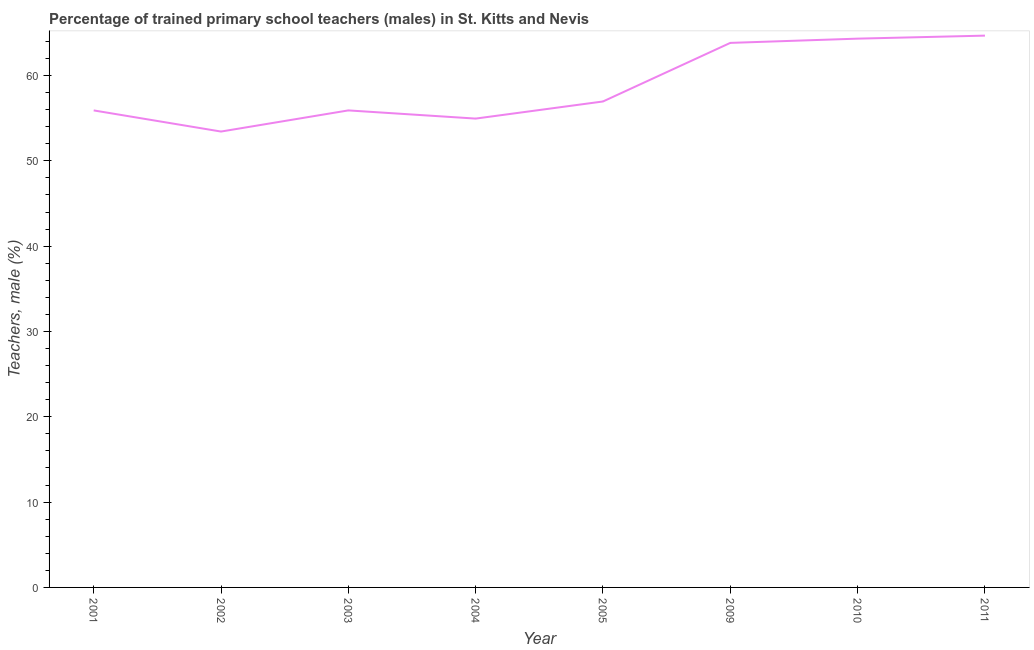What is the percentage of trained male teachers in 2002?
Ensure brevity in your answer.  53.43. Across all years, what is the maximum percentage of trained male teachers?
Ensure brevity in your answer.  64.68. Across all years, what is the minimum percentage of trained male teachers?
Your answer should be compact. 53.43. What is the sum of the percentage of trained male teachers?
Offer a very short reply. 469.99. What is the difference between the percentage of trained male teachers in 2005 and 2011?
Make the answer very short. -7.72. What is the average percentage of trained male teachers per year?
Offer a very short reply. 58.75. What is the median percentage of trained male teachers?
Ensure brevity in your answer.  56.43. In how many years, is the percentage of trained male teachers greater than 36 %?
Your answer should be very brief. 8. Do a majority of the years between 2009 and 2011 (inclusive) have percentage of trained male teachers greater than 46 %?
Your answer should be very brief. Yes. What is the ratio of the percentage of trained male teachers in 2004 to that in 2010?
Provide a succinct answer. 0.85. Is the percentage of trained male teachers in 2003 less than that in 2010?
Make the answer very short. Yes. Is the difference between the percentage of trained male teachers in 2003 and 2004 greater than the difference between any two years?
Provide a short and direct response. No. What is the difference between the highest and the second highest percentage of trained male teachers?
Your answer should be compact. 0.35. Is the sum of the percentage of trained male teachers in 2002 and 2005 greater than the maximum percentage of trained male teachers across all years?
Your answer should be very brief. Yes. What is the difference between the highest and the lowest percentage of trained male teachers?
Offer a very short reply. 11.24. In how many years, is the percentage of trained male teachers greater than the average percentage of trained male teachers taken over all years?
Offer a very short reply. 3. Does the percentage of trained male teachers monotonically increase over the years?
Provide a succinct answer. No. Are the values on the major ticks of Y-axis written in scientific E-notation?
Provide a succinct answer. No. Does the graph contain any zero values?
Ensure brevity in your answer.  No. What is the title of the graph?
Ensure brevity in your answer.  Percentage of trained primary school teachers (males) in St. Kitts and Nevis. What is the label or title of the X-axis?
Ensure brevity in your answer.  Year. What is the label or title of the Y-axis?
Provide a succinct answer. Teachers, male (%). What is the Teachers, male (%) of 2001?
Ensure brevity in your answer.  55.91. What is the Teachers, male (%) of 2002?
Your response must be concise. 53.43. What is the Teachers, male (%) in 2003?
Keep it short and to the point. 55.91. What is the Teachers, male (%) in 2004?
Provide a succinct answer. 54.95. What is the Teachers, male (%) of 2005?
Offer a very short reply. 56.96. What is the Teachers, male (%) of 2009?
Ensure brevity in your answer.  63.82. What is the Teachers, male (%) of 2010?
Your answer should be compact. 64.32. What is the Teachers, male (%) of 2011?
Offer a terse response. 64.68. What is the difference between the Teachers, male (%) in 2001 and 2002?
Offer a very short reply. 2.48. What is the difference between the Teachers, male (%) in 2001 and 2004?
Provide a short and direct response. 0.96. What is the difference between the Teachers, male (%) in 2001 and 2005?
Your answer should be compact. -1.05. What is the difference between the Teachers, male (%) in 2001 and 2009?
Make the answer very short. -7.91. What is the difference between the Teachers, male (%) in 2001 and 2010?
Your answer should be very brief. -8.41. What is the difference between the Teachers, male (%) in 2001 and 2011?
Your answer should be compact. -8.77. What is the difference between the Teachers, male (%) in 2002 and 2003?
Your answer should be compact. -2.48. What is the difference between the Teachers, male (%) in 2002 and 2004?
Offer a very short reply. -1.52. What is the difference between the Teachers, male (%) in 2002 and 2005?
Your answer should be very brief. -3.53. What is the difference between the Teachers, male (%) in 2002 and 2009?
Give a very brief answer. -10.39. What is the difference between the Teachers, male (%) in 2002 and 2010?
Give a very brief answer. -10.89. What is the difference between the Teachers, male (%) in 2002 and 2011?
Provide a short and direct response. -11.24. What is the difference between the Teachers, male (%) in 2003 and 2004?
Provide a short and direct response. 0.96. What is the difference between the Teachers, male (%) in 2003 and 2005?
Your answer should be compact. -1.05. What is the difference between the Teachers, male (%) in 2003 and 2009?
Offer a very short reply. -7.91. What is the difference between the Teachers, male (%) in 2003 and 2010?
Offer a very short reply. -8.41. What is the difference between the Teachers, male (%) in 2003 and 2011?
Offer a very short reply. -8.77. What is the difference between the Teachers, male (%) in 2004 and 2005?
Keep it short and to the point. -2.01. What is the difference between the Teachers, male (%) in 2004 and 2009?
Make the answer very short. -8.87. What is the difference between the Teachers, male (%) in 2004 and 2010?
Your response must be concise. -9.37. What is the difference between the Teachers, male (%) in 2004 and 2011?
Your answer should be compact. -9.72. What is the difference between the Teachers, male (%) in 2005 and 2009?
Your response must be concise. -6.87. What is the difference between the Teachers, male (%) in 2005 and 2010?
Provide a short and direct response. -7.36. What is the difference between the Teachers, male (%) in 2005 and 2011?
Offer a very short reply. -7.72. What is the difference between the Teachers, male (%) in 2009 and 2010?
Offer a terse response. -0.5. What is the difference between the Teachers, male (%) in 2009 and 2011?
Provide a short and direct response. -0.85. What is the difference between the Teachers, male (%) in 2010 and 2011?
Offer a terse response. -0.35. What is the ratio of the Teachers, male (%) in 2001 to that in 2002?
Your answer should be compact. 1.05. What is the ratio of the Teachers, male (%) in 2001 to that in 2004?
Your answer should be very brief. 1.02. What is the ratio of the Teachers, male (%) in 2001 to that in 2005?
Your answer should be very brief. 0.98. What is the ratio of the Teachers, male (%) in 2001 to that in 2009?
Your answer should be very brief. 0.88. What is the ratio of the Teachers, male (%) in 2001 to that in 2010?
Make the answer very short. 0.87. What is the ratio of the Teachers, male (%) in 2001 to that in 2011?
Give a very brief answer. 0.86. What is the ratio of the Teachers, male (%) in 2002 to that in 2003?
Your response must be concise. 0.96. What is the ratio of the Teachers, male (%) in 2002 to that in 2005?
Make the answer very short. 0.94. What is the ratio of the Teachers, male (%) in 2002 to that in 2009?
Make the answer very short. 0.84. What is the ratio of the Teachers, male (%) in 2002 to that in 2010?
Your answer should be very brief. 0.83. What is the ratio of the Teachers, male (%) in 2002 to that in 2011?
Offer a very short reply. 0.83. What is the ratio of the Teachers, male (%) in 2003 to that in 2004?
Your answer should be very brief. 1.02. What is the ratio of the Teachers, male (%) in 2003 to that in 2005?
Keep it short and to the point. 0.98. What is the ratio of the Teachers, male (%) in 2003 to that in 2009?
Your answer should be compact. 0.88. What is the ratio of the Teachers, male (%) in 2003 to that in 2010?
Your answer should be compact. 0.87. What is the ratio of the Teachers, male (%) in 2003 to that in 2011?
Keep it short and to the point. 0.86. What is the ratio of the Teachers, male (%) in 2004 to that in 2009?
Your answer should be very brief. 0.86. What is the ratio of the Teachers, male (%) in 2004 to that in 2010?
Your answer should be very brief. 0.85. What is the ratio of the Teachers, male (%) in 2004 to that in 2011?
Offer a very short reply. 0.85. What is the ratio of the Teachers, male (%) in 2005 to that in 2009?
Your response must be concise. 0.89. What is the ratio of the Teachers, male (%) in 2005 to that in 2010?
Make the answer very short. 0.89. What is the ratio of the Teachers, male (%) in 2005 to that in 2011?
Provide a short and direct response. 0.88. What is the ratio of the Teachers, male (%) in 2010 to that in 2011?
Your answer should be very brief. 0.99. 